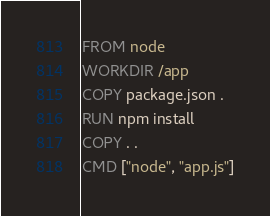Convert code to text. <code><loc_0><loc_0><loc_500><loc_500><_Dockerfile_>FROM node
WORKDIR /app
COPY package.json .
RUN npm install
COPY . .
CMD ["node", "app.js"]</code> 